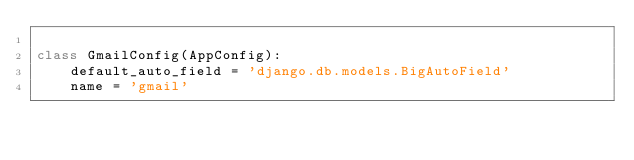Convert code to text. <code><loc_0><loc_0><loc_500><loc_500><_Python_>
class GmailConfig(AppConfig):
    default_auto_field = 'django.db.models.BigAutoField'
    name = 'gmail'
</code> 